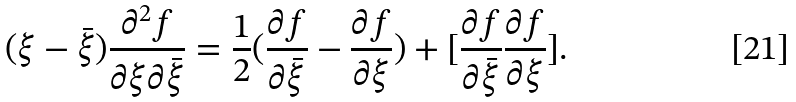Convert formula to latex. <formula><loc_0><loc_0><loc_500><loc_500>( \xi - \bar { \xi } ) \frac { \partial ^ { 2 } f } { \partial \xi \partial \bar { \xi } } = \frac { 1 } { 2 } ( \frac { \partial f } { \partial \bar { \xi } } - \frac { \partial f } { \partial \xi } ) + [ \frac { \partial f } { \partial \bar { \xi } } \frac { \partial f } { \partial \xi } ] .</formula> 